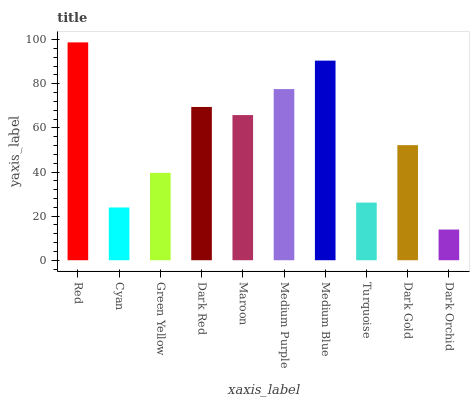Is Cyan the minimum?
Answer yes or no. No. Is Cyan the maximum?
Answer yes or no. No. Is Red greater than Cyan?
Answer yes or no. Yes. Is Cyan less than Red?
Answer yes or no. Yes. Is Cyan greater than Red?
Answer yes or no. No. Is Red less than Cyan?
Answer yes or no. No. Is Maroon the high median?
Answer yes or no. Yes. Is Dark Gold the low median?
Answer yes or no. Yes. Is Green Yellow the high median?
Answer yes or no. No. Is Red the low median?
Answer yes or no. No. 